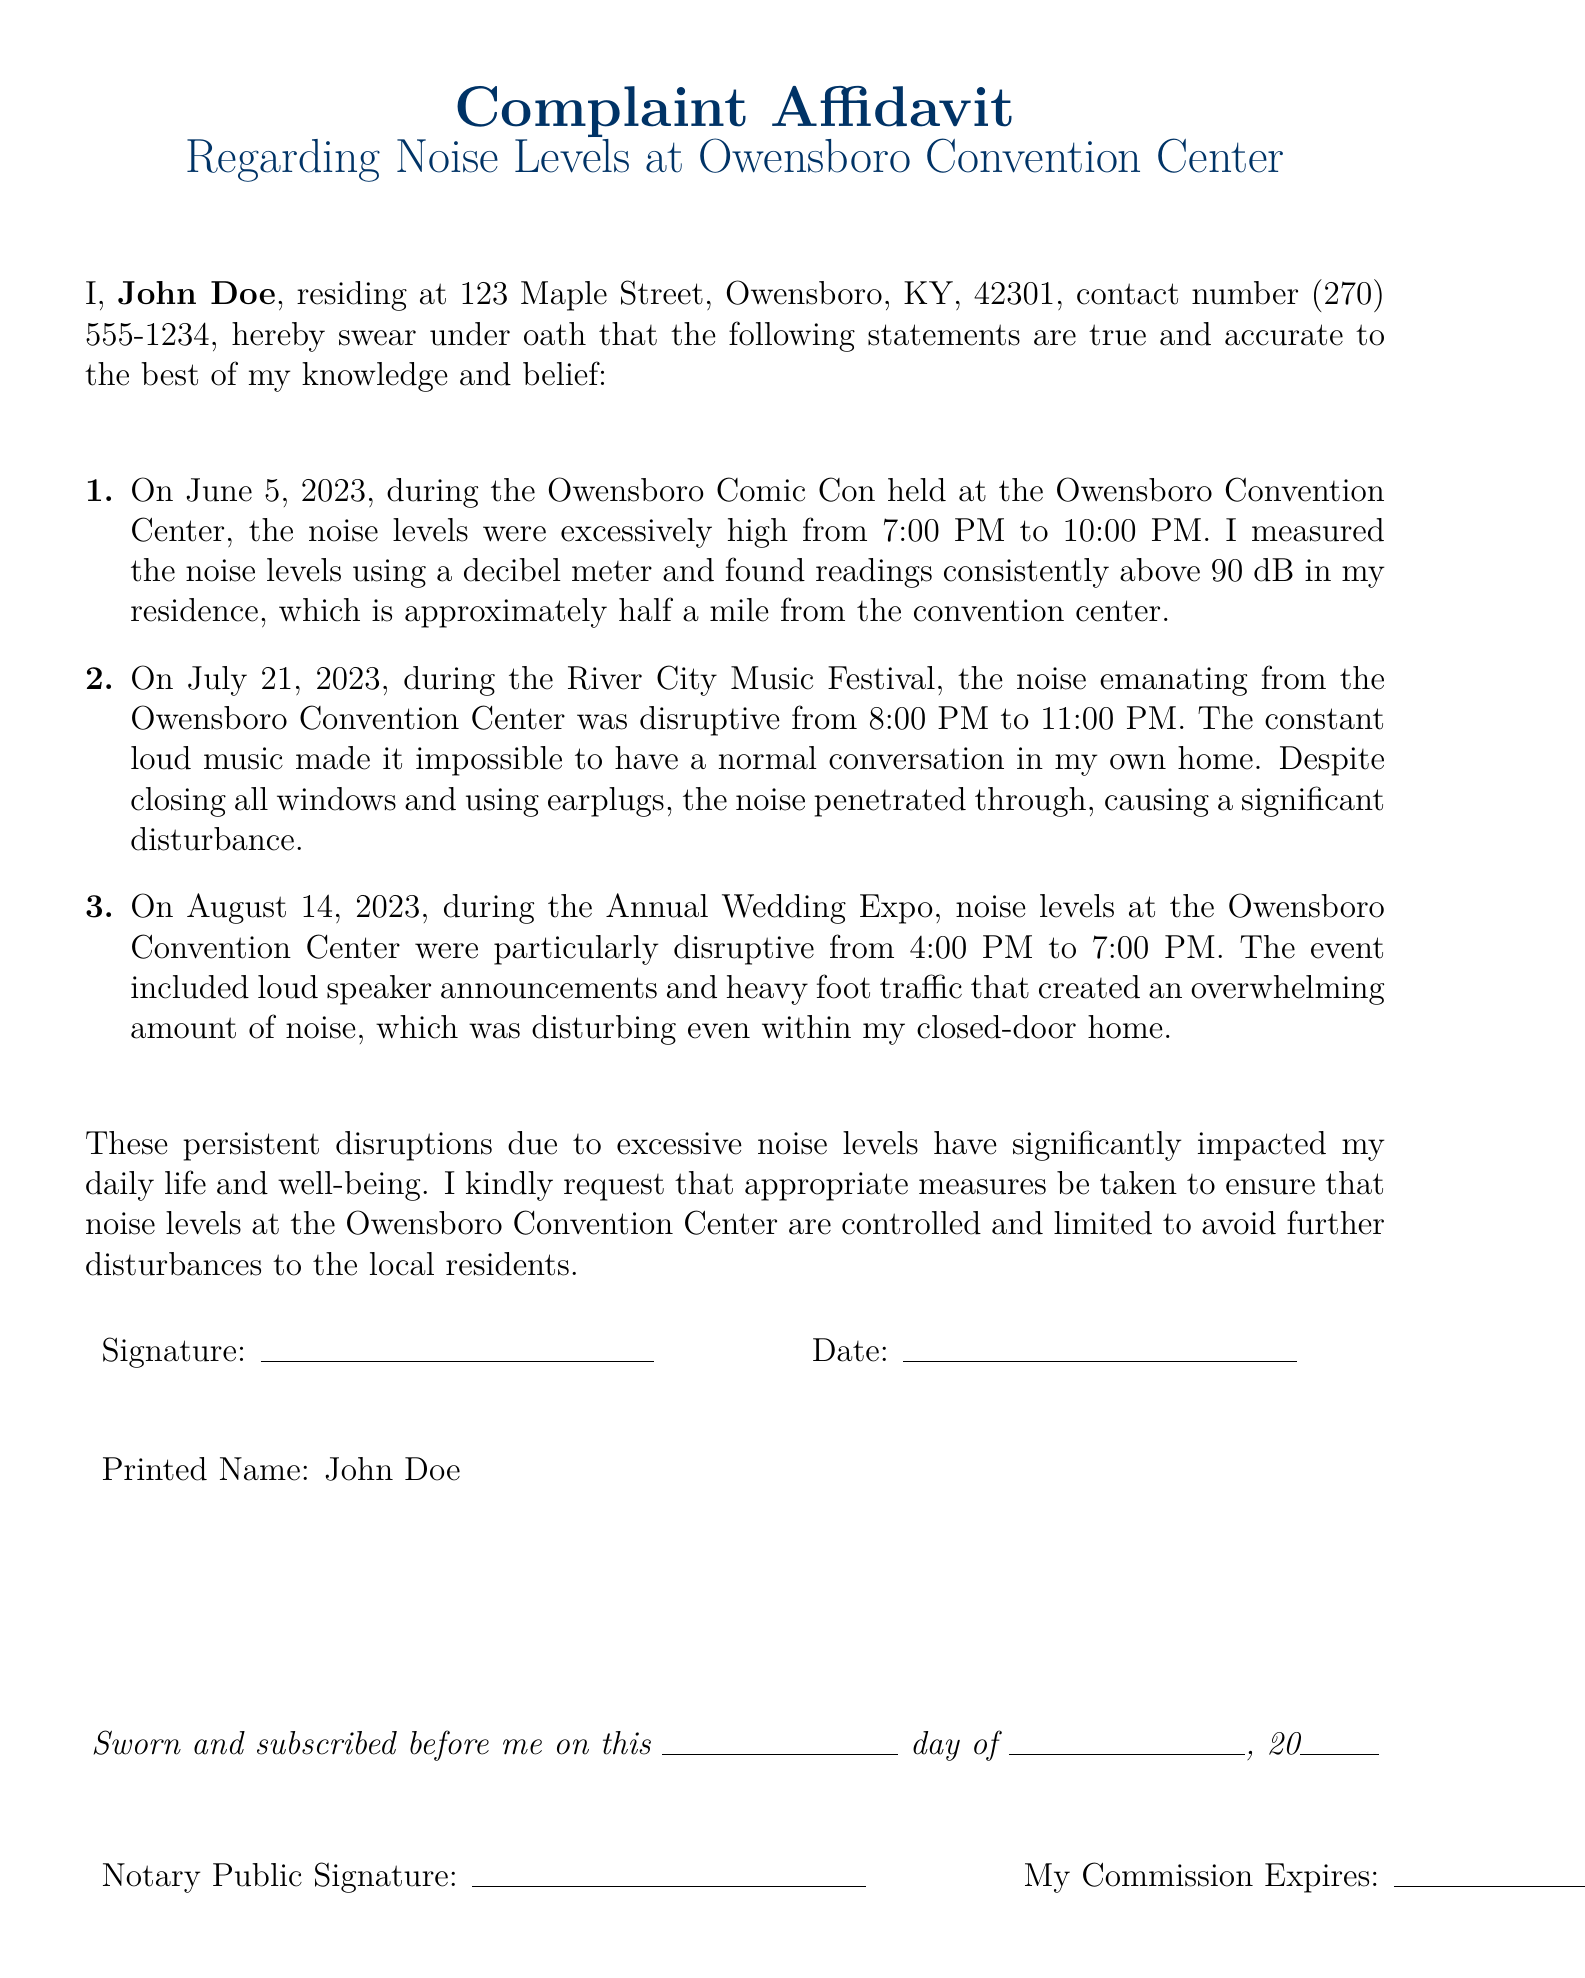What is the name of the complainant? The complainant's name is provided at the beginning of the affidavit.
Answer: John Doe What is the address of the complainant? The address of the complainant is specified in the document.
Answer: 123 Maple Street, Owensboro, KY, 42301 On what date did the Owensboro Comic Con take place? The specific date of the event is mentioned in the document.
Answer: June 5, 2023 What were the noise levels measured during the Comic Con? The affidavit provides the noise levels recorded during the event as evidence of the disturbance.
Answer: consistently above 90 dB What time did the River City Music Festival occur? The document specifies the hours during which the festival occurred.
Answer: 8:00 PM to 11:00 PM What specific event took place on August 14, 2023? The document lists various events and includes this date with its corresponding event.
Answer: Annual Wedding Expo During which event did the complainant experience disruptions from 4:00 PM to 7:00 PM? The affidavit clearly associates this time frame with a specific event.
Answer: Annual Wedding Expo What did the complainant request in the affidavit? The complainant's request is stated towards the end of the document.
Answer: that noise levels at the Owensboro Convention Center are controlled Who must sign and subscribe the affidavit? The document specifies the individuals involved in the signing process.
Answer: Notary Public 